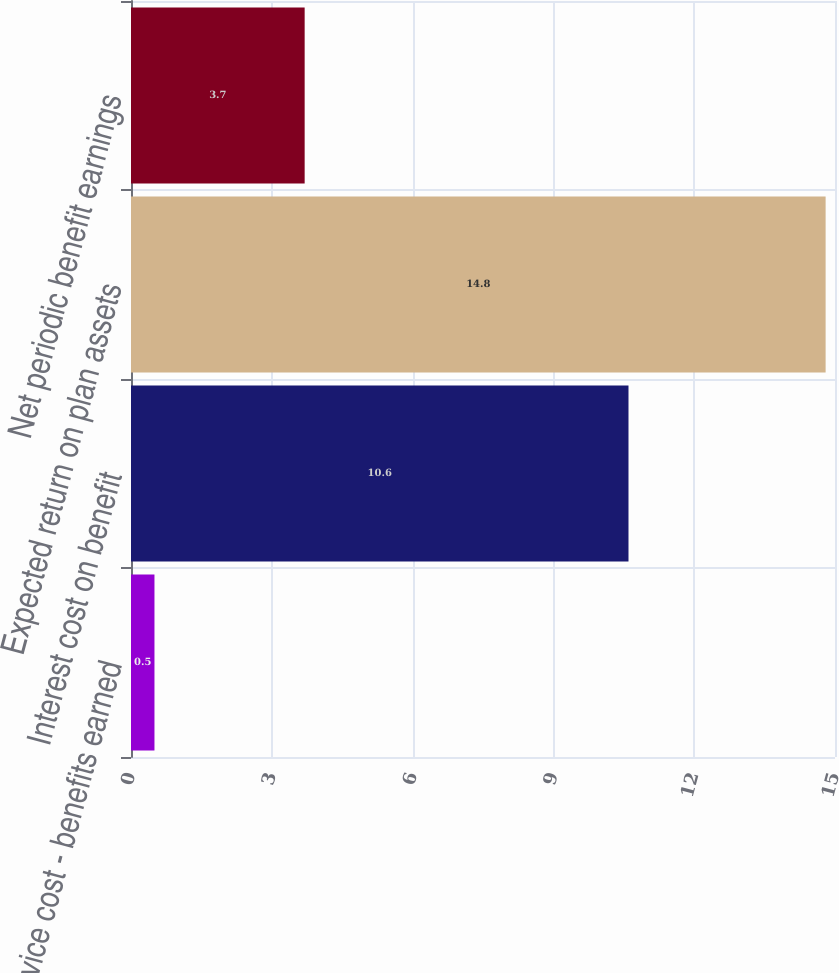<chart> <loc_0><loc_0><loc_500><loc_500><bar_chart><fcel>Service cost - benefits earned<fcel>Interest cost on benefit<fcel>Expected return on plan assets<fcel>Net periodic benefit earnings<nl><fcel>0.5<fcel>10.6<fcel>14.8<fcel>3.7<nl></chart> 